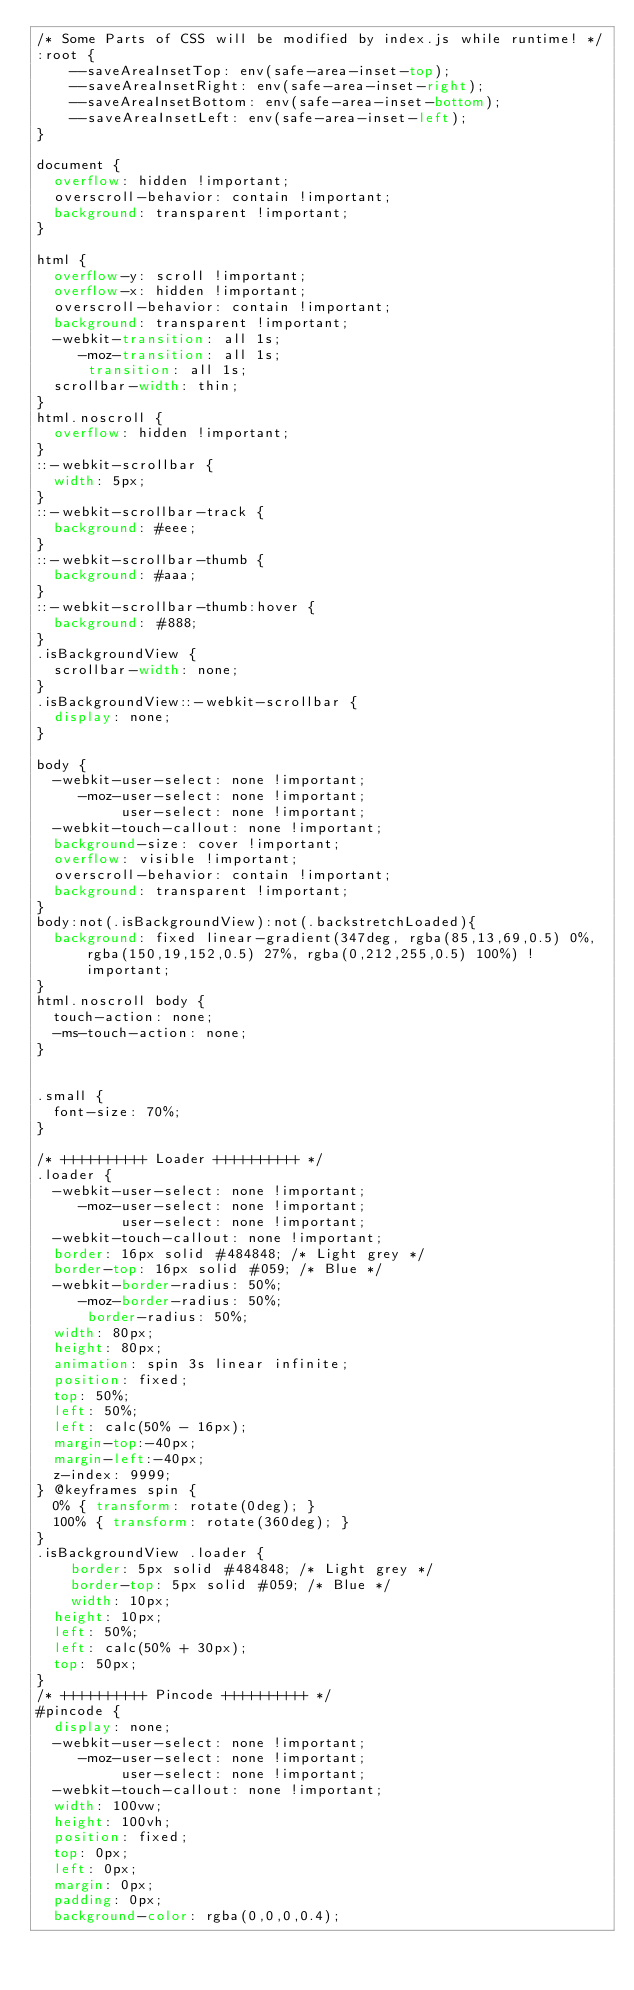<code> <loc_0><loc_0><loc_500><loc_500><_CSS_>/* Some Parts of CSS will be modified by index.js while runtime! */
:root {
    --saveAreaInsetTop: env(safe-area-inset-top);
    --saveAreaInsetRight: env(safe-area-inset-right);
    --saveAreaInsetBottom: env(safe-area-inset-bottom);
    --saveAreaInsetLeft: env(safe-area-inset-left);
}

document {
	overflow: hidden !important;
	overscroll-behavior: contain !important;
	background: transparent !important;
}

html {
	overflow-y: scroll !important;
	overflow-x: hidden !important;
	overscroll-behavior: contain !important;
	background: transparent !important;
	-webkit-transition: all 1s;
	   -moz-transition: all 1s;
			transition: all 1s;
	scrollbar-width: thin;
}
html.noscroll {
	overflow: hidden !important;
}
::-webkit-scrollbar {
  width: 5px;
}
::-webkit-scrollbar-track {
  background: #eee;
}
::-webkit-scrollbar-thumb {
  background: #aaa; 
}
::-webkit-scrollbar-thumb:hover {
  background: #888; 
}
.isBackgroundView {
  scrollbar-width: none;
}
.isBackgroundView::-webkit-scrollbar {
  display: none;
}

body {
	-webkit-user-select: none !important;
	   -moz-user-select: none !important; 
	        user-select: none !important;
	-webkit-touch-callout: none !important;
	background-size: cover !important;
	overflow: visible !important;
	overscroll-behavior: contain !important;
	background: transparent !important;
}
body:not(.isBackgroundView):not(.backstretchLoaded){
	background: fixed linear-gradient(347deg, rgba(85,13,69,0.5) 0%, rgba(150,19,152,0.5) 27%, rgba(0,212,255,0.5) 100%) !important;
}
html.noscroll body {
	touch-action: none;
	-ms-touch-action: none;
}


.small {
	font-size: 70%;
}

/* ++++++++++ Loader ++++++++++ */ 
.loader {
	-webkit-user-select: none !important;
	   -moz-user-select: none !important; 
	        user-select: none !important;
	-webkit-touch-callout: none !important;
	border: 16px solid #484848; /* Light grey */
	border-top: 16px solid #059; /* Blue */
	-webkit-border-radius: 50%;
	   -moz-border-radius: 50%;
			border-radius: 50%;
	width: 80px;
	height: 80px;
	animation: spin 3s linear infinite;
	position: fixed;
	top: 50%;
	left: 50%;
	left: calc(50% - 16px);
	margin-top:-40px;
	margin-left:-40px;
	z-index: 9999;
} @keyframes spin {
	0% { transform: rotate(0deg); }
	100% { transform: rotate(360deg); }
}
.isBackgroundView .loader {   
    border: 5px solid #484848; /* Light grey */	
    border-top: 5px solid #059; /* Blue */
    width: 10px;
	height: 10px;
	left: 50%;
	left: calc(50% + 30px);
	top: 50px;
}
/* ++++++++++ Pincode ++++++++++ */ 
#pincode {
	display: none;
	-webkit-user-select: none !important;
	   -moz-user-select: none !important; 
	        user-select: none !important;
	-webkit-touch-callout: none !important;
	width: 100vw;
	height: 100vh;
	position: fixed;
	top: 0px;
	left: 0px;
	margin: 0px;
	padding: 0px;
	background-color: rgba(0,0,0,0.4);</code> 